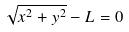Convert formula to latex. <formula><loc_0><loc_0><loc_500><loc_500>\sqrt { x ^ { 2 } + y ^ { 2 } } - L = 0</formula> 